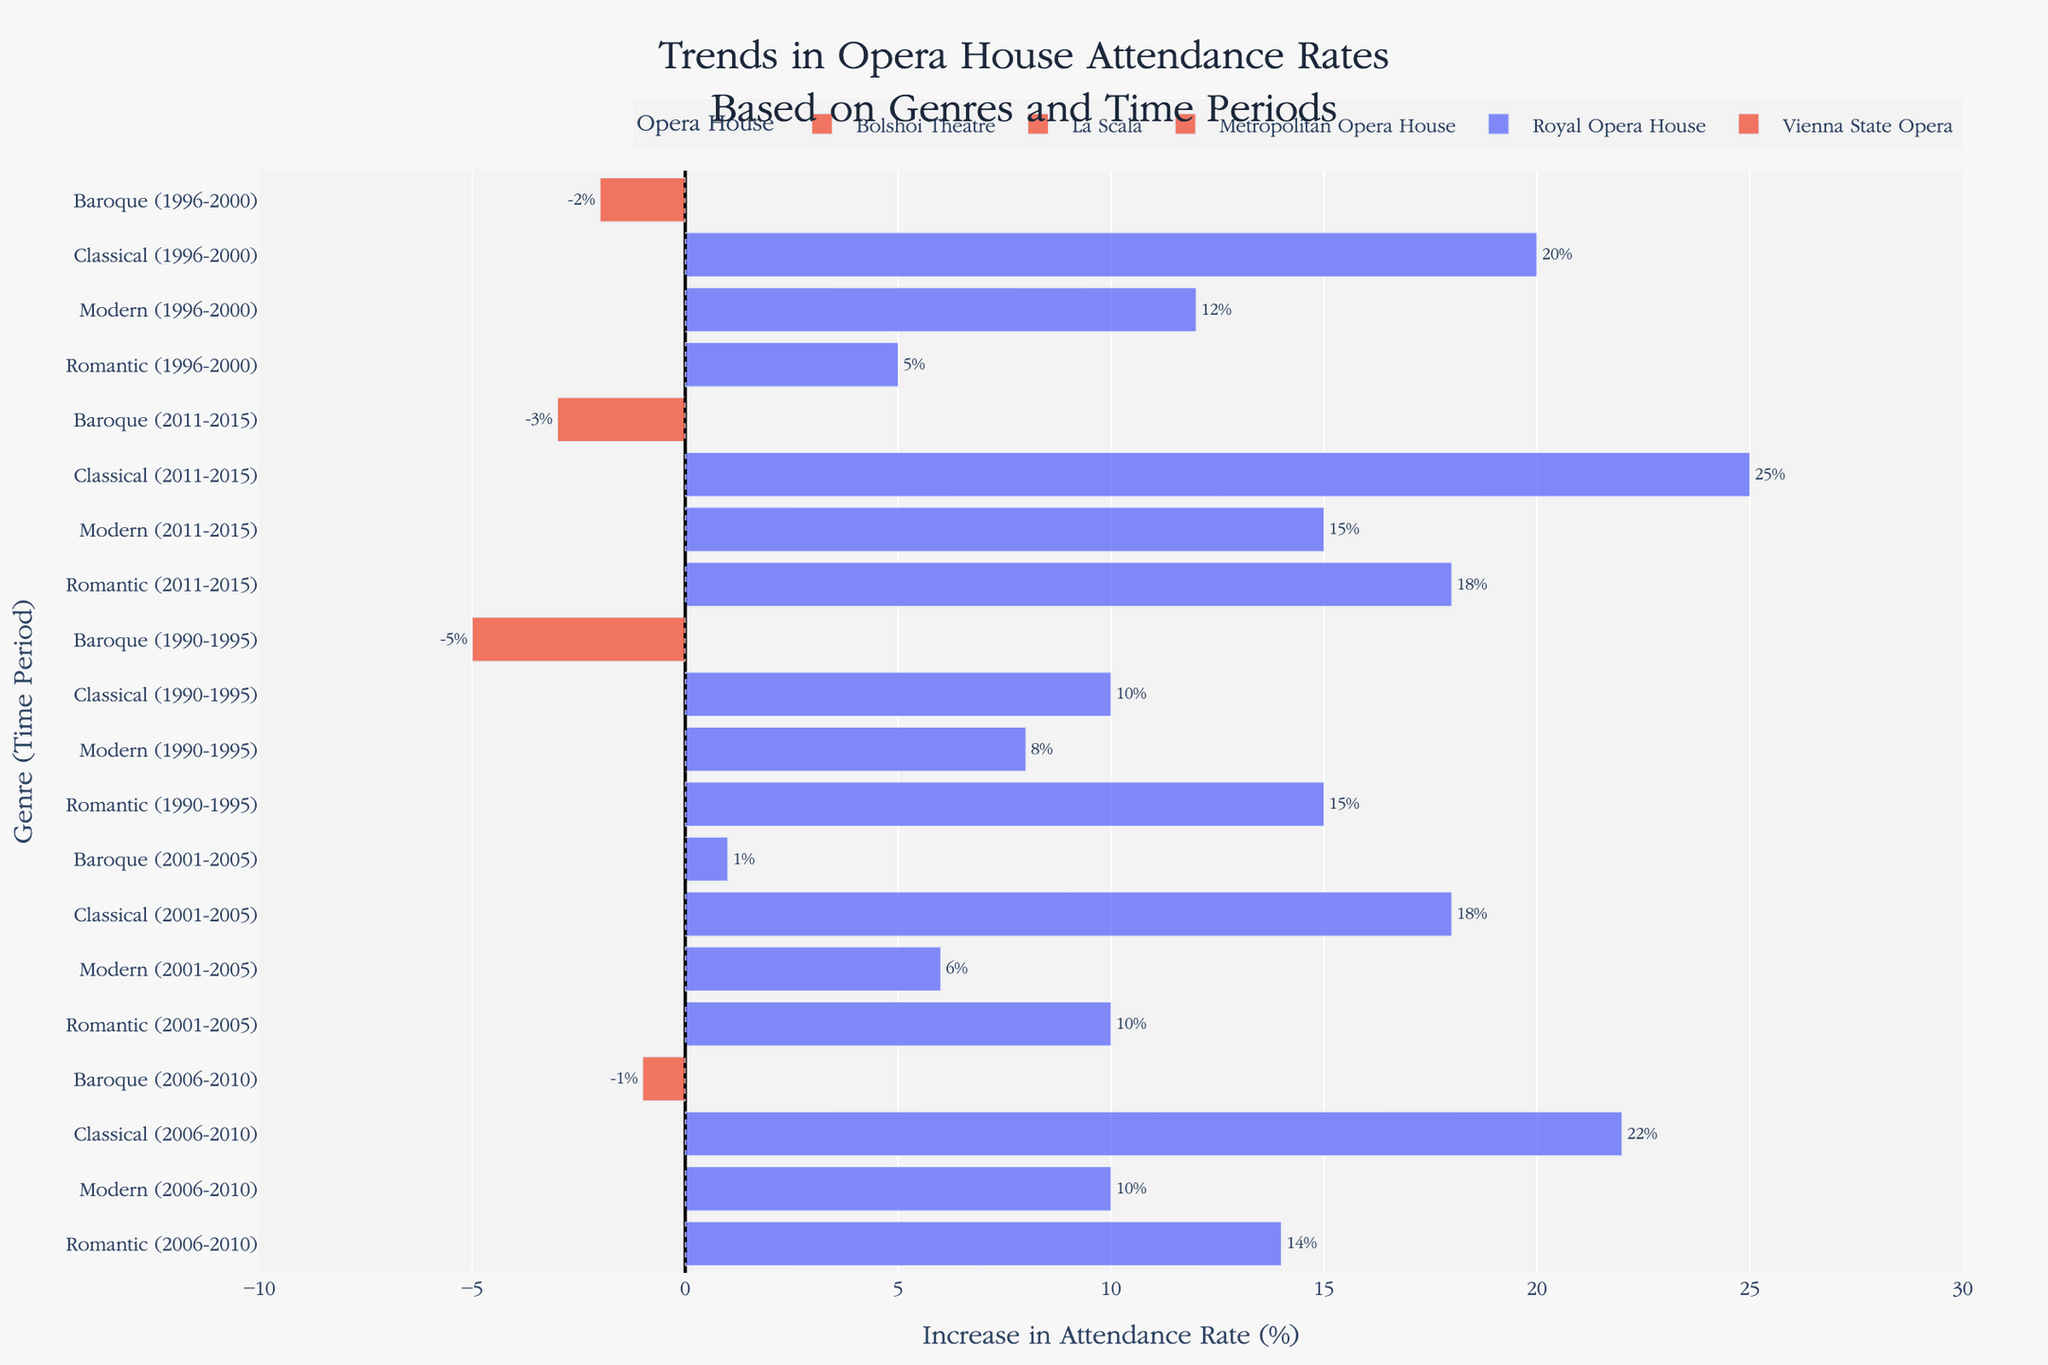What's the overall increase or decrease in attendance rates for Baroque operas across all time periods and opera houses? To determine the overall change, sum up the attendance rates for Baroque operas for each listed period: -5 (1990-1995) + (-2) (1996-2000) + 1 (2001-2005) + (-1) (2006-2010) + (-3) (2011-2015). This yields -5 + (-2) + 1 + (-1) + (-3) = -10%.
Answer: -10% Which opera house had the highest increase in attendance rates for Classical operas? Review each bar representing Classical operas across different opera houses and time periods. La Scala during 2011-2015 had the highest increase at 25%.
Answer: La Scala How does the attendance rate change for Romantic operas from the 1996-2000 period to the 2006-2010 period at the Bolshoi Theatre? Compare the bar for Romantic operas at Bolshoi Theatre from 1996-2000 (5%) to that from 2006-2010 (14%). The change in rate is 14% - 5% = 9%.
Answer: Increased by 9% What is the average increase in attendance rates for Modern operas at all listed opera houses and time periods? To find the average, sum the attendance rates for Modern operas: 8 (1990-1995) + 12 (1996-2000) + 6 (2001-2005) + 10 (2006-2010) + 15 (2011-2015) = 51%. Then, divide by the number of periods: 51 / 5 = 10.2%.
Answer: 10.2% Between Baroque and Modern operas in the 2001-2005 period, which had a higher attendance rate at the Royal Opera House? Compare the bars for Baroque (1%) and Modern (6%) operas. Modern operas had a higher rate.
Answer: Modern operas Which opera house had a negative attendance rate change for Baroque operas in the 1990-1995 period? Among the listed periods for Baroque operas in 1990-1995, the bar for Metropolitan Opera House is below zero, indicating a negative change of -5%.
Answer: Metropolitan Opera House How much did the attendance rate for Classical operas increase at the Vienna State Opera from 2001-2005 to 2006-2010? Compare the bars for the Vienna State Opera's Classical operas in 2001-2005 (18%) and 2006-2010 (22%). The increase is calculated as 22% - 18% = 4%.
Answer: 4% Did La Scala experience a positive or negative change in attendance rate for Modern operas from 2011-2015? Observe the Modern opera bar at La Scala during 2011-2015. It shows a positive change with an increase of 15%.
Answer: Positive 